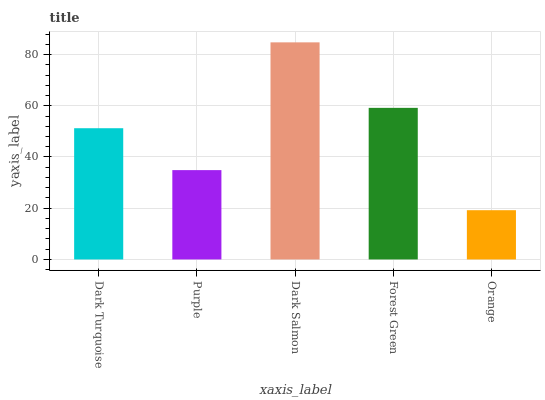Is Purple the minimum?
Answer yes or no. No. Is Purple the maximum?
Answer yes or no. No. Is Dark Turquoise greater than Purple?
Answer yes or no. Yes. Is Purple less than Dark Turquoise?
Answer yes or no. Yes. Is Purple greater than Dark Turquoise?
Answer yes or no. No. Is Dark Turquoise less than Purple?
Answer yes or no. No. Is Dark Turquoise the high median?
Answer yes or no. Yes. Is Dark Turquoise the low median?
Answer yes or no. Yes. Is Forest Green the high median?
Answer yes or no. No. Is Forest Green the low median?
Answer yes or no. No. 